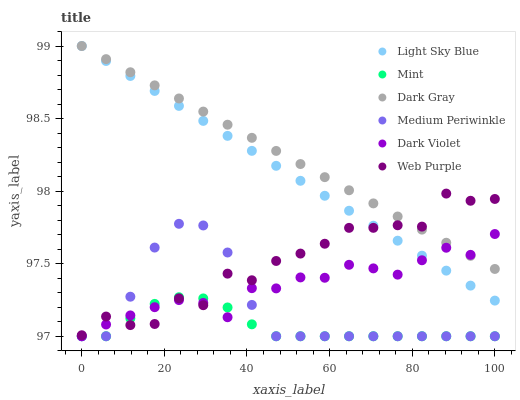Does Mint have the minimum area under the curve?
Answer yes or no. Yes. Does Dark Gray have the maximum area under the curve?
Answer yes or no. Yes. Does Dark Violet have the minimum area under the curve?
Answer yes or no. No. Does Dark Violet have the maximum area under the curve?
Answer yes or no. No. Is Light Sky Blue the smoothest?
Answer yes or no. Yes. Is Web Purple the roughest?
Answer yes or no. Yes. Is Dark Violet the smoothest?
Answer yes or no. No. Is Dark Violet the roughest?
Answer yes or no. No. Does Medium Periwinkle have the lowest value?
Answer yes or no. Yes. Does Dark Gray have the lowest value?
Answer yes or no. No. Does Light Sky Blue have the highest value?
Answer yes or no. Yes. Does Dark Violet have the highest value?
Answer yes or no. No. Is Medium Periwinkle less than Dark Gray?
Answer yes or no. Yes. Is Light Sky Blue greater than Mint?
Answer yes or no. Yes. Does Medium Periwinkle intersect Dark Violet?
Answer yes or no. Yes. Is Medium Periwinkle less than Dark Violet?
Answer yes or no. No. Is Medium Periwinkle greater than Dark Violet?
Answer yes or no. No. Does Medium Periwinkle intersect Dark Gray?
Answer yes or no. No. 